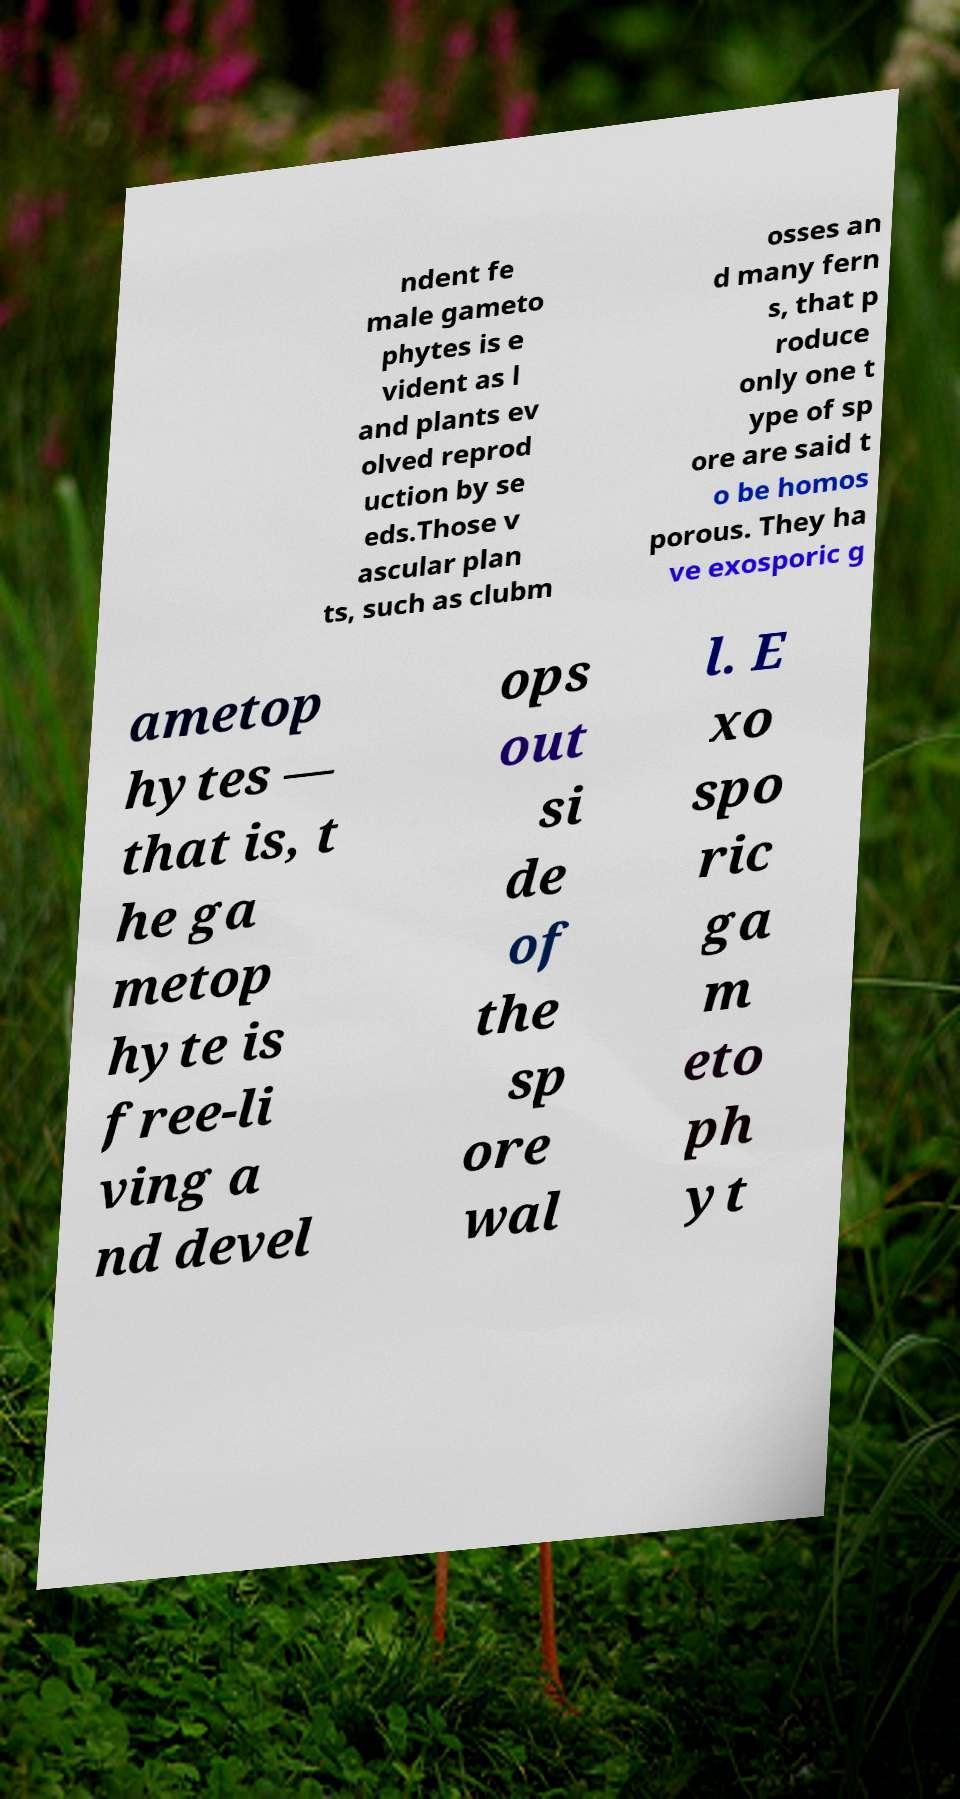Please read and relay the text visible in this image. What does it say? ndent fe male gameto phytes is e vident as l and plants ev olved reprod uction by se eds.Those v ascular plan ts, such as clubm osses an d many fern s, that p roduce only one t ype of sp ore are said t o be homos porous. They ha ve exosporic g ametop hytes — that is, t he ga metop hyte is free-li ving a nd devel ops out si de of the sp ore wal l. E xo spo ric ga m eto ph yt 